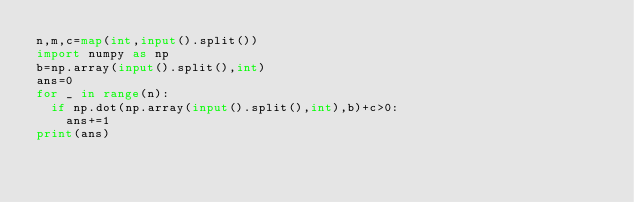Convert code to text. <code><loc_0><loc_0><loc_500><loc_500><_Python_>n,m,c=map(int,input().split())
import numpy as np
b=np.array(input().split(),int)
ans=0
for _ in range(n):
  if np.dot(np.array(input().split(),int),b)+c>0:
    ans+=1
print(ans)</code> 